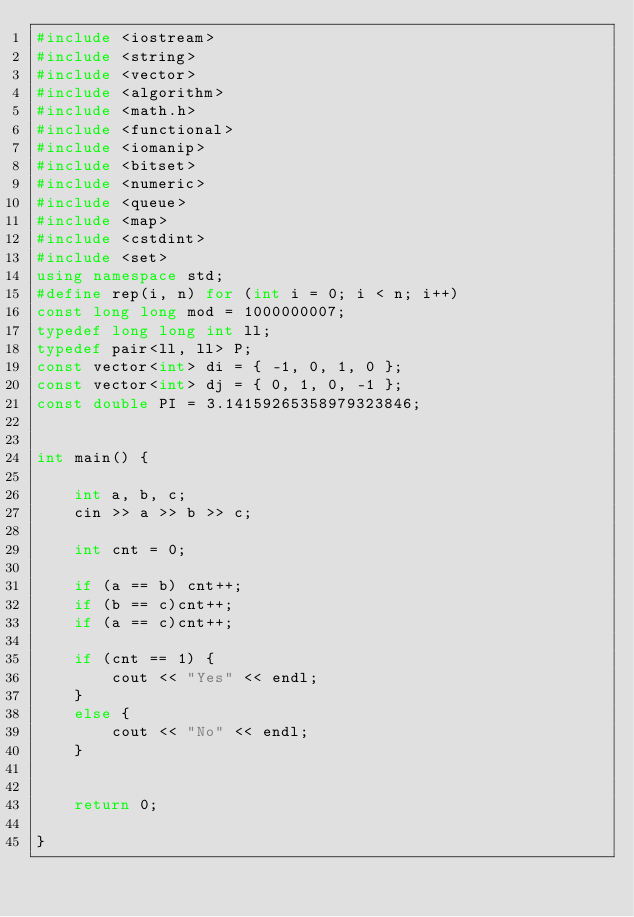<code> <loc_0><loc_0><loc_500><loc_500><_C++_>#include <iostream>
#include <string>
#include <vector>
#include <algorithm>
#include <math.h>
#include <functional>
#include <iomanip>
#include <bitset>
#include <numeric>
#include <queue>
#include <map>
#include <cstdint>
#include <set>
using namespace std;
#define rep(i, n) for (int i = 0; i < n; i++)
const long long mod = 1000000007;
typedef long long int ll;
typedef pair<ll, ll> P;
const vector<int> di = { -1, 0, 1, 0 };
const vector<int> dj = { 0, 1, 0, -1 };
const double PI = 3.14159265358979323846;


int main() {

	int a, b, c;
	cin >> a >> b >> c;

	int cnt = 0;

	if (a == b) cnt++;
	if (b == c)cnt++;
	if (a == c)cnt++;

	if (cnt == 1) {
		cout << "Yes" << endl;
	}
	else {
		cout << "No" << endl;
	}


	return 0;

}


</code> 